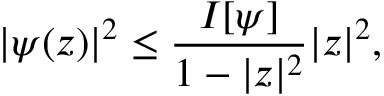Convert formula to latex. <formula><loc_0><loc_0><loc_500><loc_500>| \psi ( z ) | ^ { 2 } \leq { \frac { I [ \psi ] } { 1 - | z | ^ { 2 } } } | z | ^ { 2 } ,</formula> 